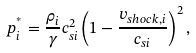<formula> <loc_0><loc_0><loc_500><loc_500>p _ { i } ^ { ^ { * } } = \frac { \rho _ { i } } { \gamma } c _ { s i } ^ { 2 } \left ( 1 - \frac { v _ { s h o c k , i } } { c _ { s i } } \right ) ^ { 2 } ,</formula> 